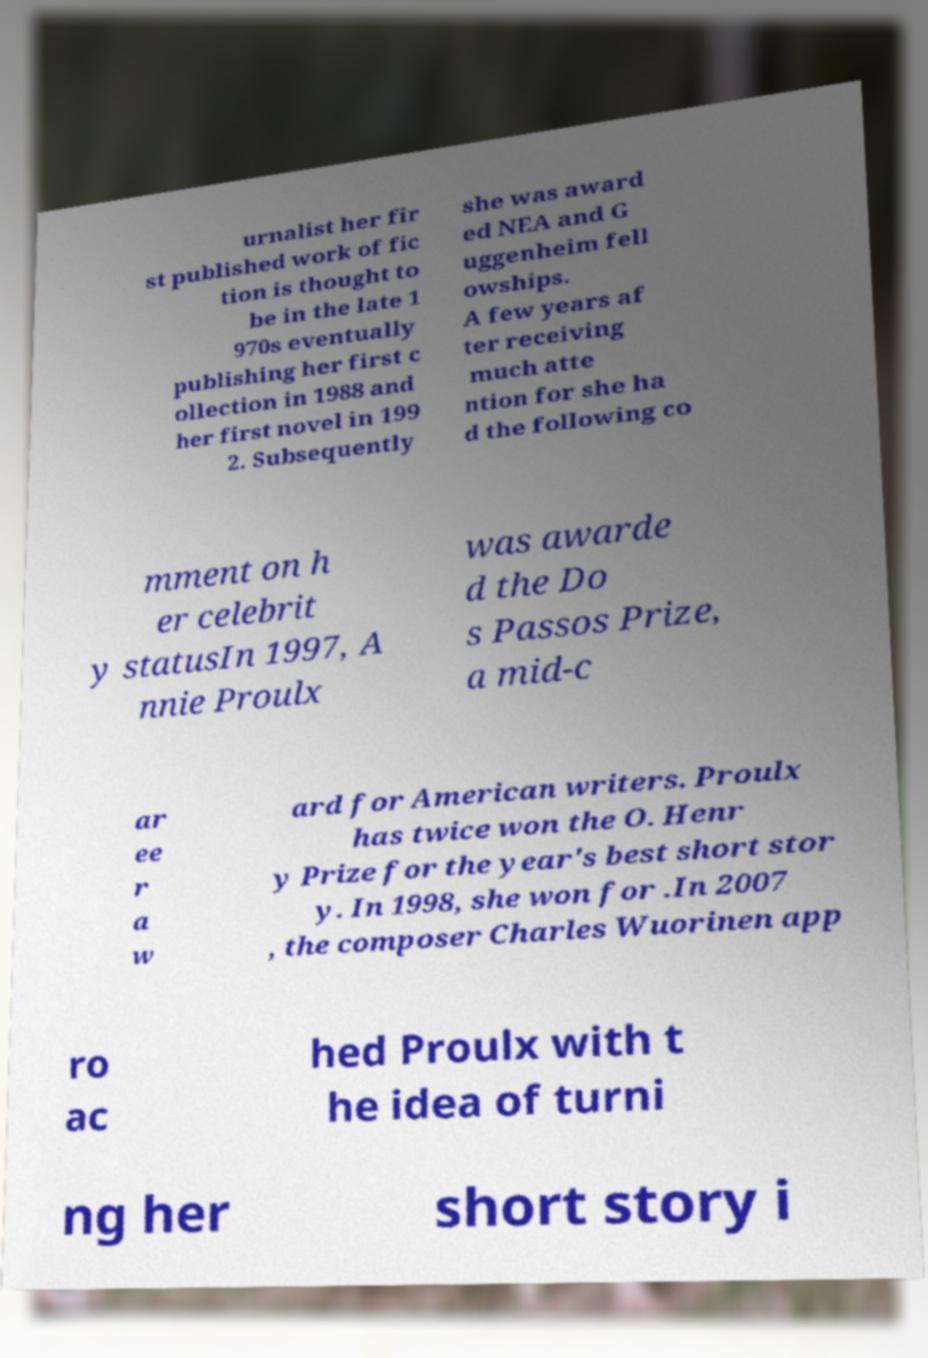Could you assist in decoding the text presented in this image and type it out clearly? urnalist her fir st published work of fic tion is thought to be in the late 1 970s eventually publishing her first c ollection in 1988 and her first novel in 199 2. Subsequently she was award ed NEA and G uggenheim fell owships. A few years af ter receiving much atte ntion for she ha d the following co mment on h er celebrit y statusIn 1997, A nnie Proulx was awarde d the Do s Passos Prize, a mid-c ar ee r a w ard for American writers. Proulx has twice won the O. Henr y Prize for the year's best short stor y. In 1998, she won for .In 2007 , the composer Charles Wuorinen app ro ac hed Proulx with t he idea of turni ng her short story i 